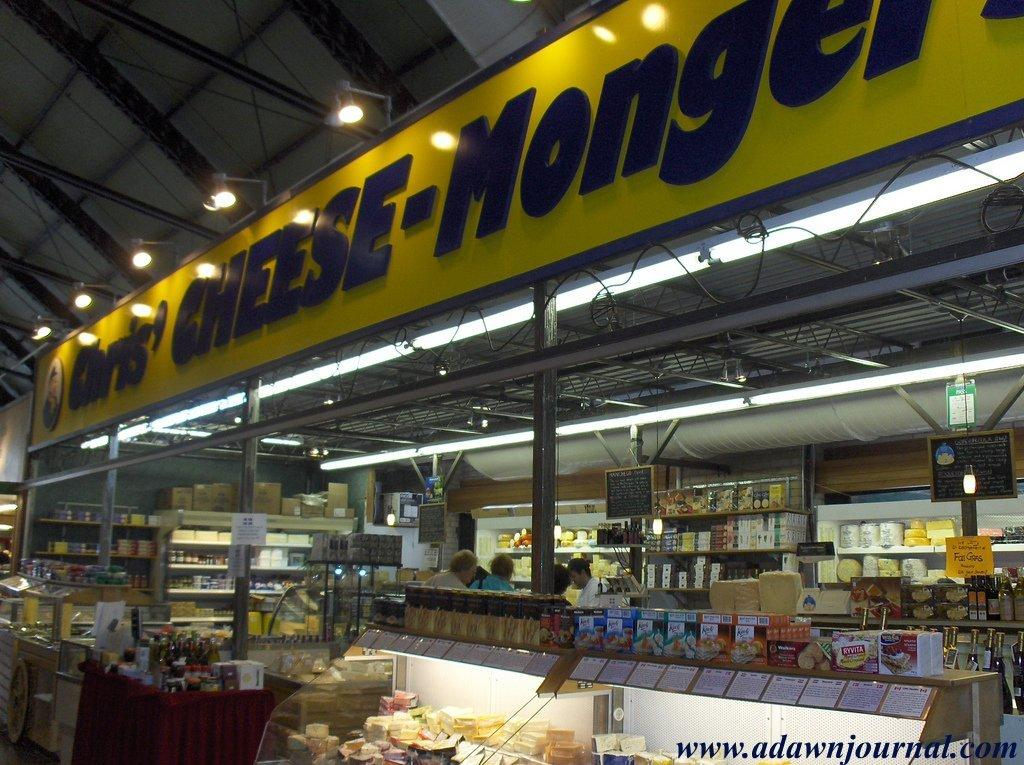<image>
Present a compact description of the photo's key features. A shop that is called Chris' and that sells cheese. 